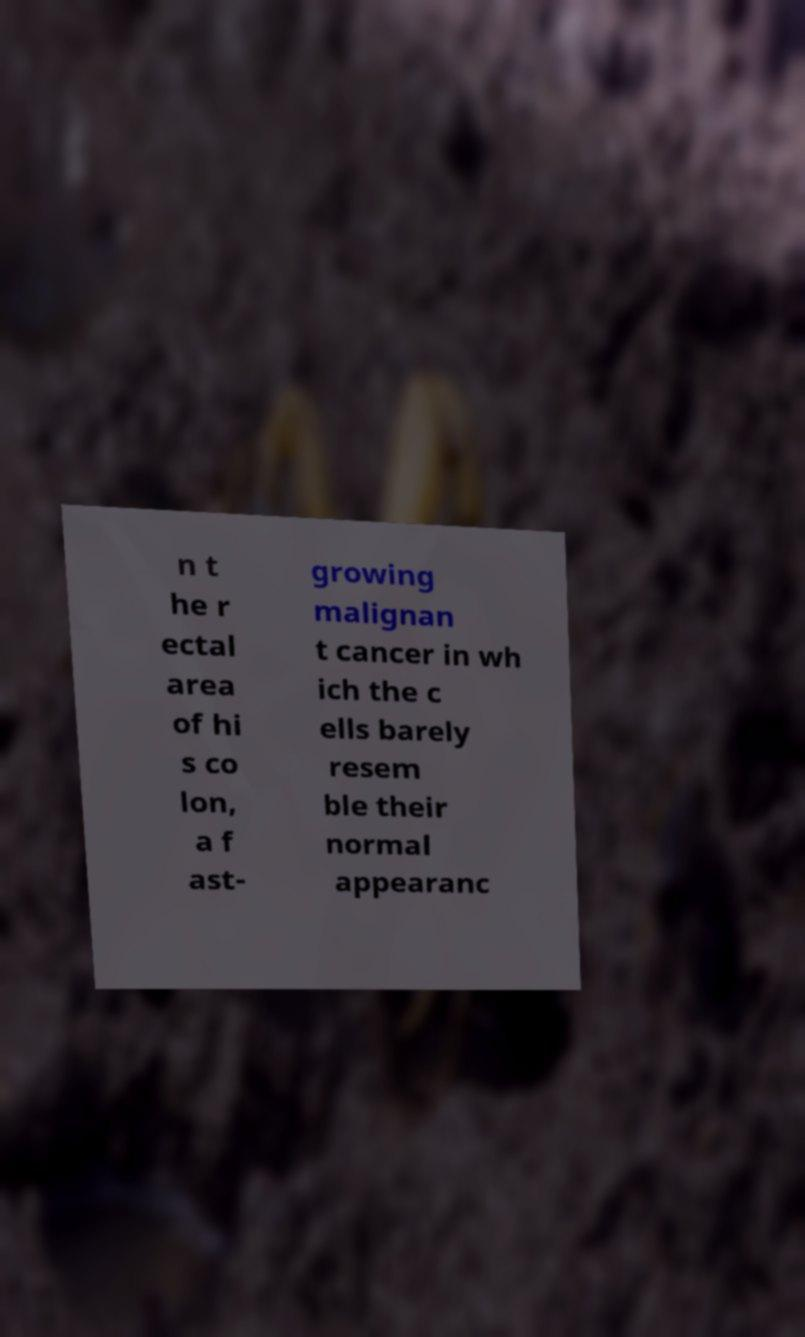For documentation purposes, I need the text within this image transcribed. Could you provide that? n t he r ectal area of hi s co lon, a f ast- growing malignan t cancer in wh ich the c ells barely resem ble their normal appearanc 